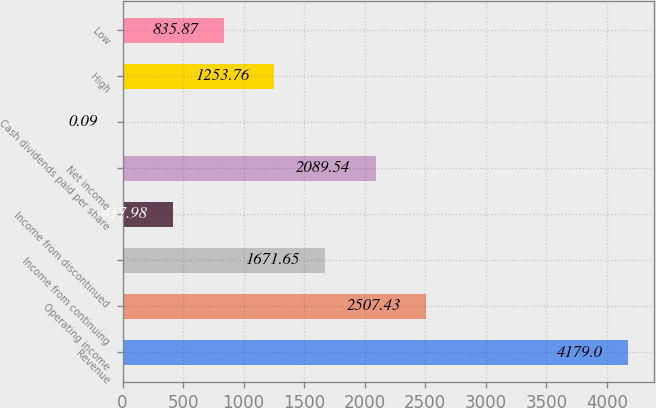Convert chart to OTSL. <chart><loc_0><loc_0><loc_500><loc_500><bar_chart><fcel>Revenue<fcel>Operating income<fcel>Income from continuing<fcel>Income from discontinued<fcel>Net income<fcel>Cash dividends paid per share<fcel>High<fcel>Low<nl><fcel>4179<fcel>2507.43<fcel>1671.65<fcel>417.98<fcel>2089.54<fcel>0.09<fcel>1253.76<fcel>835.87<nl></chart> 